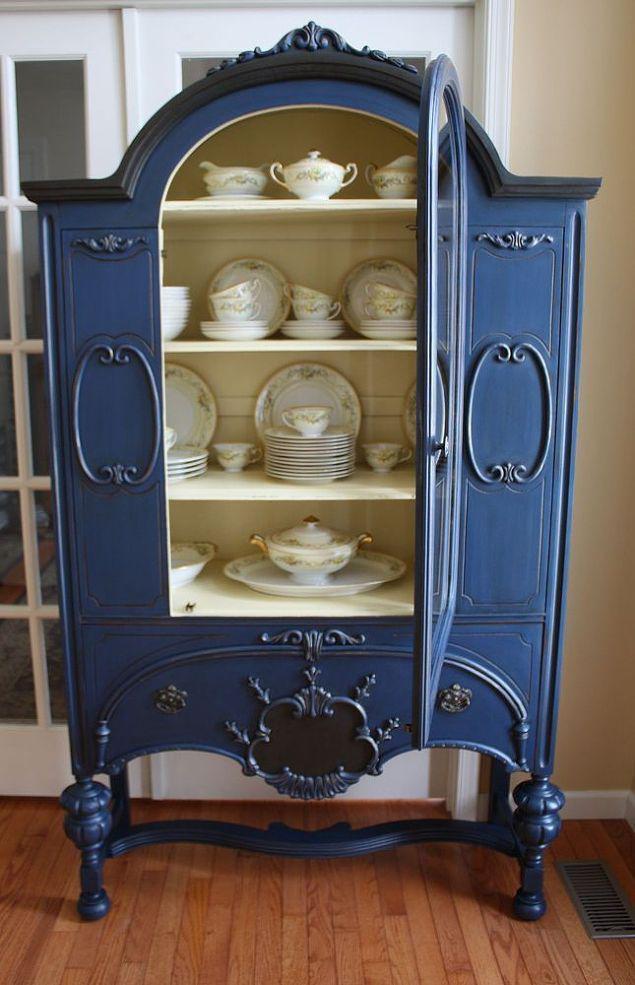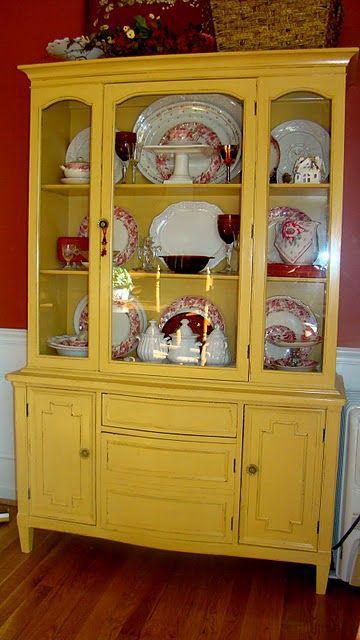The first image is the image on the left, the second image is the image on the right. Given the left and right images, does the statement "Two painted hutches both stand on legs with no glass in the bottom section, but are different colors, and one has a top curve design, while the other is flat on top." hold true? Answer yes or no. Yes. The first image is the image on the left, the second image is the image on the right. Examine the images to the left and right. Is the description "The cabinet in the left photo has a blue finish." accurate? Answer yes or no. Yes. 